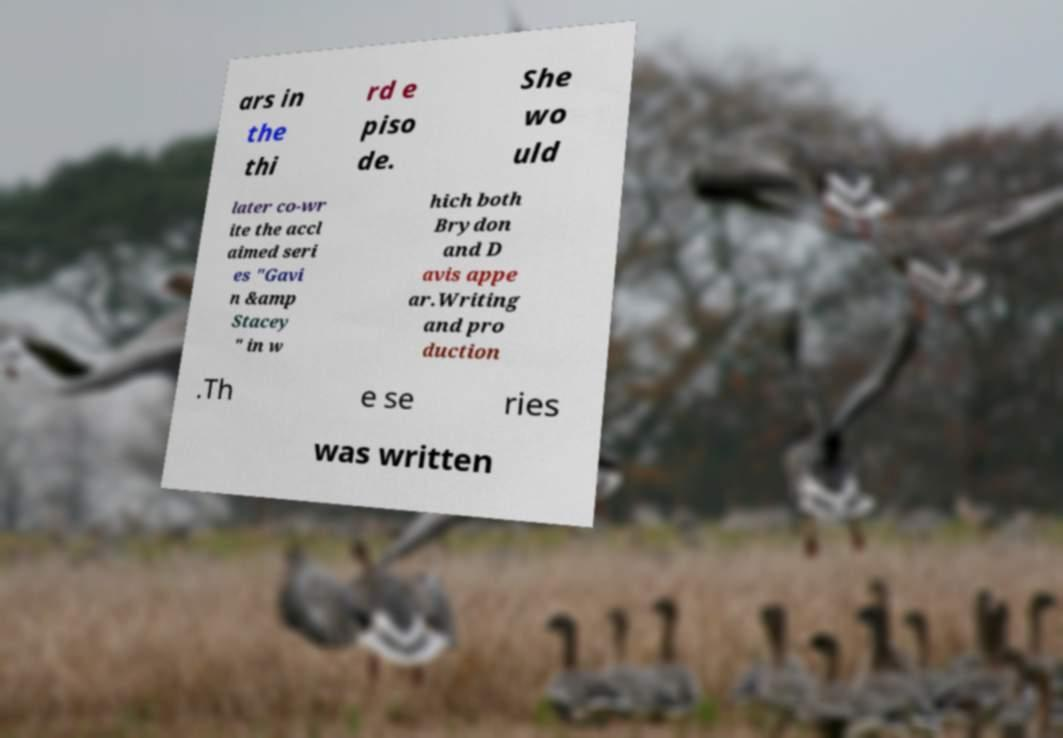Please read and relay the text visible in this image. What does it say? ars in the thi rd e piso de. She wo uld later co-wr ite the accl aimed seri es "Gavi n &amp Stacey " in w hich both Brydon and D avis appe ar.Writing and pro duction .Th e se ries was written 